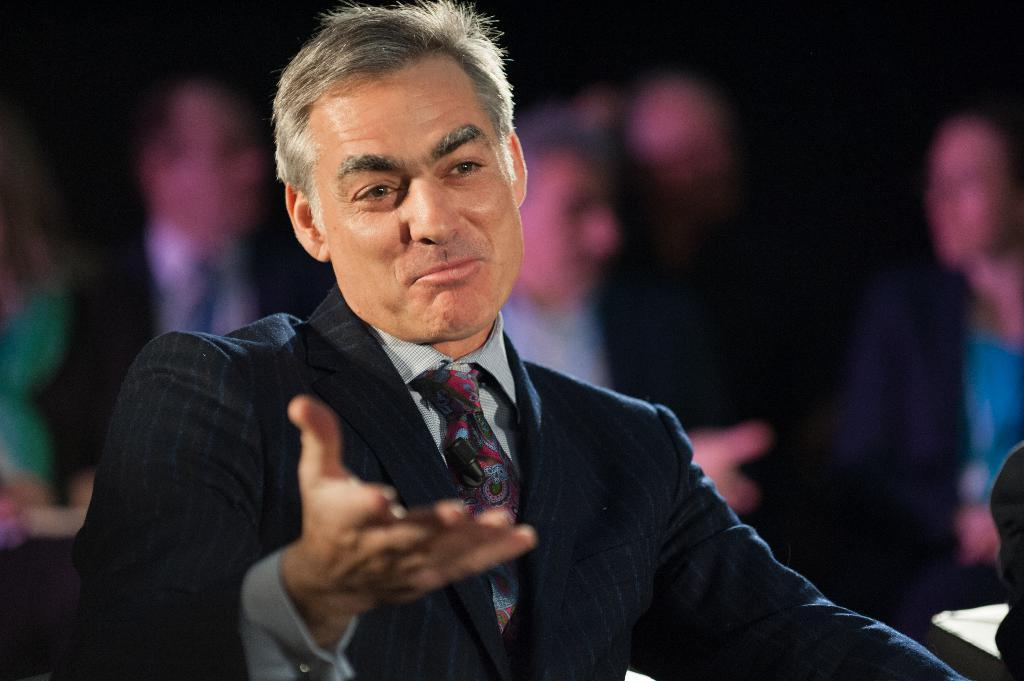What is the man in the image doing? The man is sitting in the image. What is the man wearing? The man is wearing a formal suit. Can you describe the people in the background of the image? There are other people sitting in the background of the image. How would you describe the background of the image? The background of the image is blurred. What type of poison is the man using in the image? There is no poison present in the image; the man is simply sitting down. 